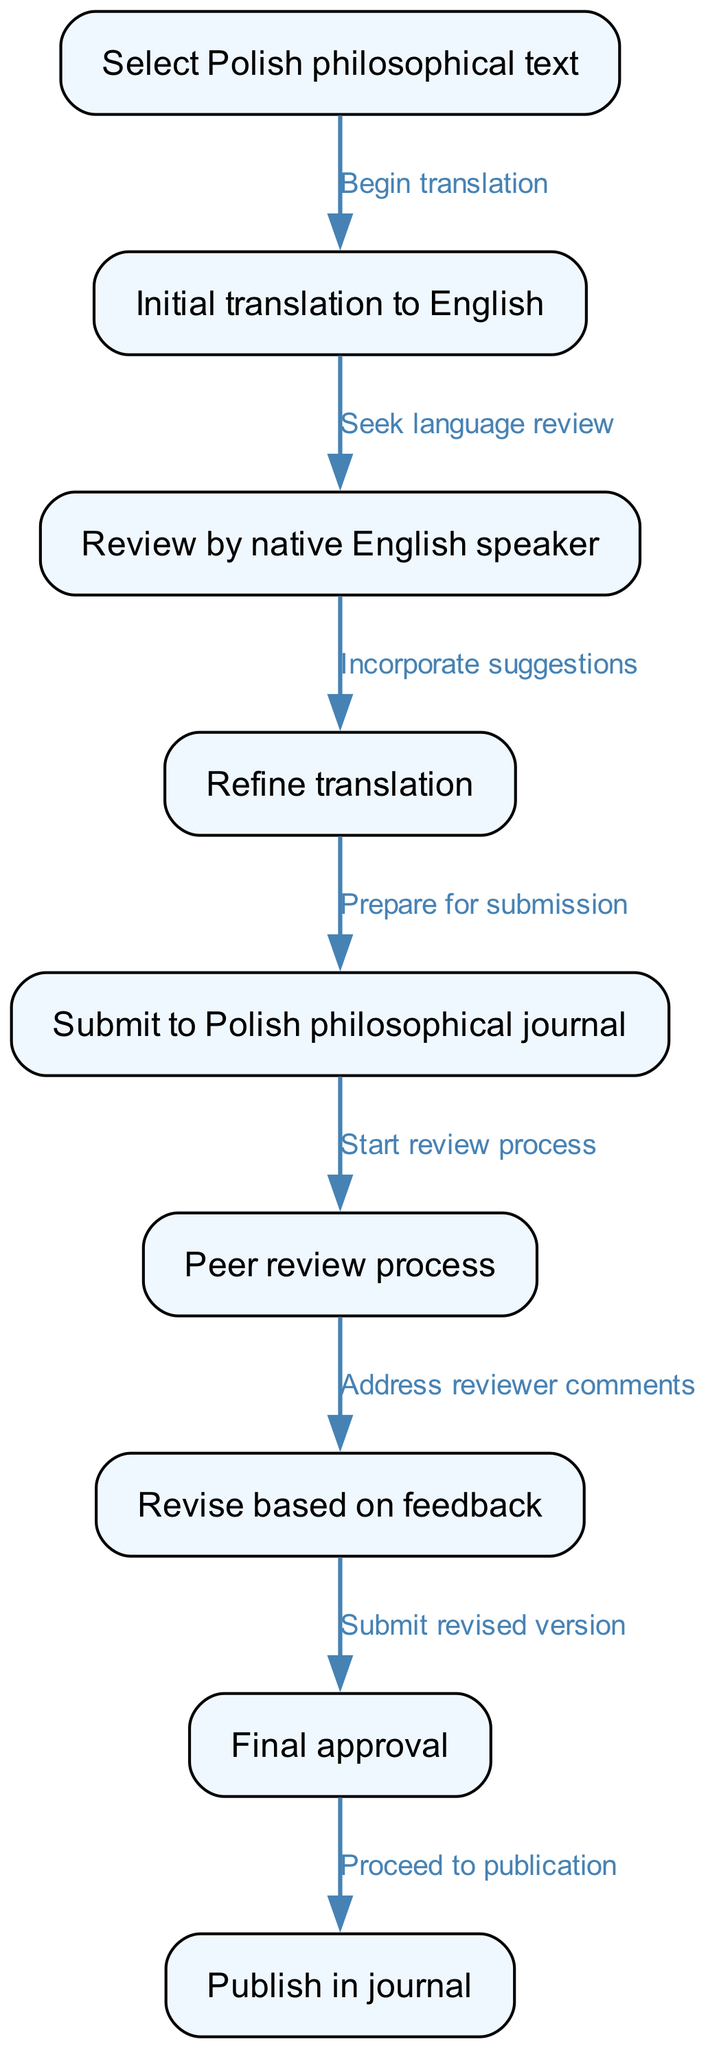What is the first step in the translation process? The flowchart begins with the node "Select Polish philosophical text," which indicates that selecting the text is the first action to be taken in the translation process.
Answer: Select Polish philosophical text How many nodes are in the diagram? The diagram has a total of nine nodes, each representing a specific step in the translation and publication process, as outlined in the data provided.
Answer: Nine What step follows the initial translation? According to the diagram, after "Initial translation to English," the next step is "Review by native English speaker," indicating a language review process.
Answer: Review by native English speaker Which node represents the process of revising based on feedback? The node titled "Revise based on feedback" represents the revision process that occurs after receiving comments from the peer review stage. This shows where the author's response to feedback is incorporated into the text.
Answer: Revise based on feedback What is the final step in the flowchart? The last node in the diagram is "Publish in journal," indicating that the final stage of the process is the actual publication of the translated work in the academic journal.
Answer: Publish in journal What step must be completed before submitting to the journal? Before submitting to the journal, the "Prepare for submission" step must be completed, which comes directly after refining the translation. This suggests that proper preparation of the text is vital prior to submission.
Answer: Prepare for submission What sequential relationship exists between node three and node four? The relationship between "Review by native English speaker" (node three) and "Refine translation" (node four) indicates that the refinement of the translation incorporates suggestions received during the review, making it critical for enhancing the quality of the translation.
Answer: Incorporate suggestions How does the peer review process start? The peer review process starts after the submission to the journal, which is indicated by the edge leading from the "Submit to Polish philosophical journal" node to the "Peer review process" node. This shows the logical progression from submission to review.
Answer: Start review process 